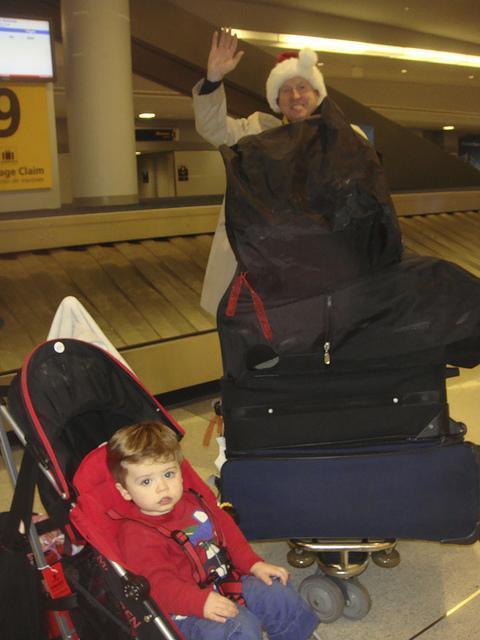How many people are in the picture?
Give a very brief answer. 2. How many suitcases are there?
Give a very brief answer. 3. How many cows do you see?
Give a very brief answer. 0. 